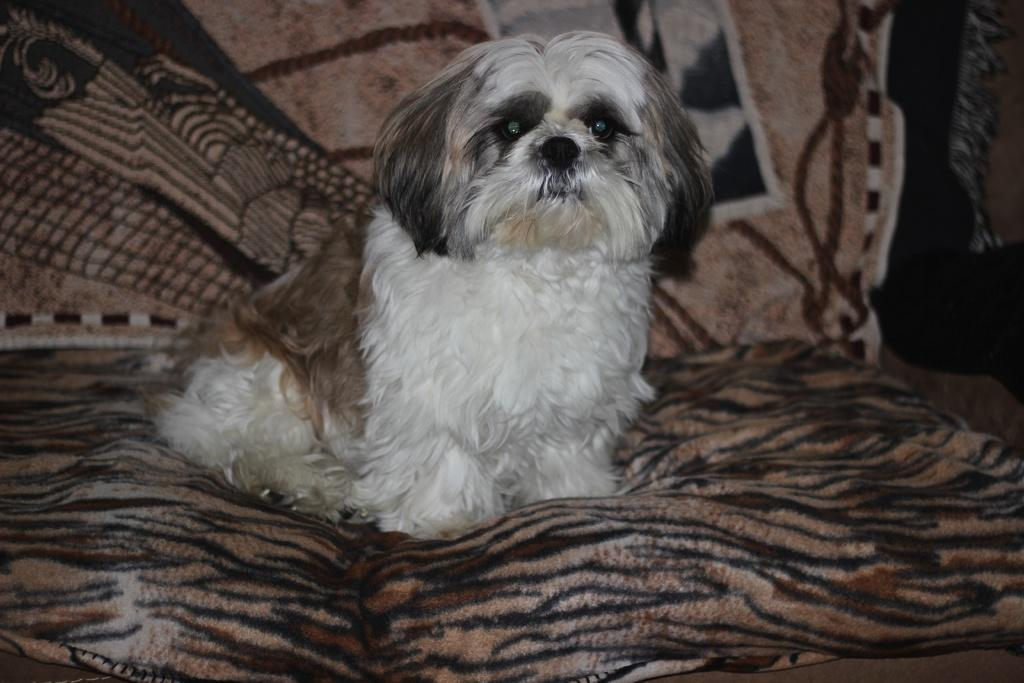What type of animal is in the image? There is a white color dog in the image. Where is the dog located in the image? The dog is sitting on a sofa. What type of liquid is the dog drinking from in the image? There is no liquid present in the image; the dog is sitting on a sofa. What kind of apparatus is the dog using to play with in the image? There is no apparatus present in the image; the dog is simply sitting on a sofa. 